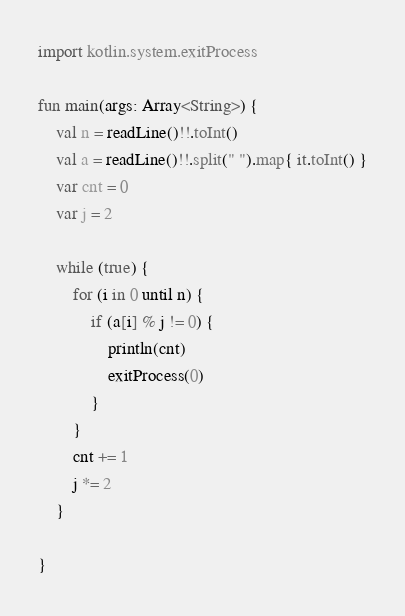Convert code to text. <code><loc_0><loc_0><loc_500><loc_500><_Kotlin_>import kotlin.system.exitProcess

fun main(args: Array<String>) {
	val n = readLine()!!.toInt()
	val a = readLine()!!.split(" ").map{ it.toInt() }
	var cnt = 0
	var j = 2

	while (true) {
		for (i in 0 until n) {
			if (a[i] % j != 0) {
				println(cnt)
				exitProcess(0)
			}
		}
		cnt += 1
		j *= 2
	}

}
</code> 